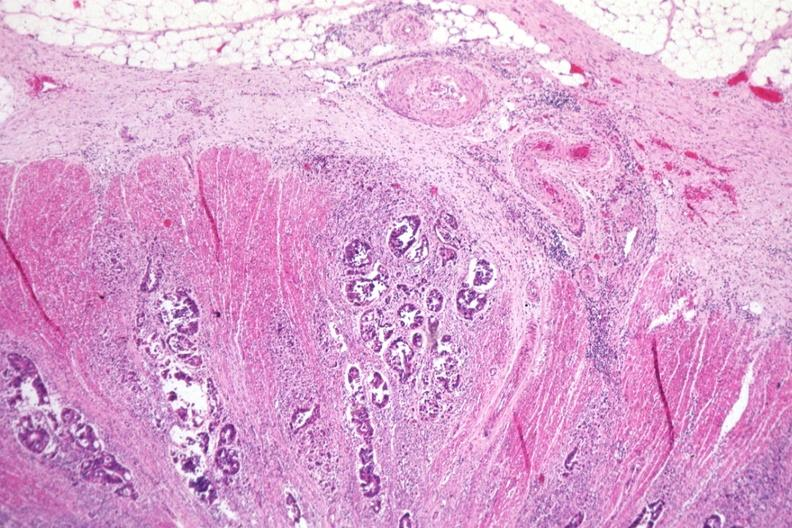does typical tuberculous exudate show excellent photo typical adenocarcinoma extending through muscularis to serosa?
Answer the question using a single word or phrase. No 